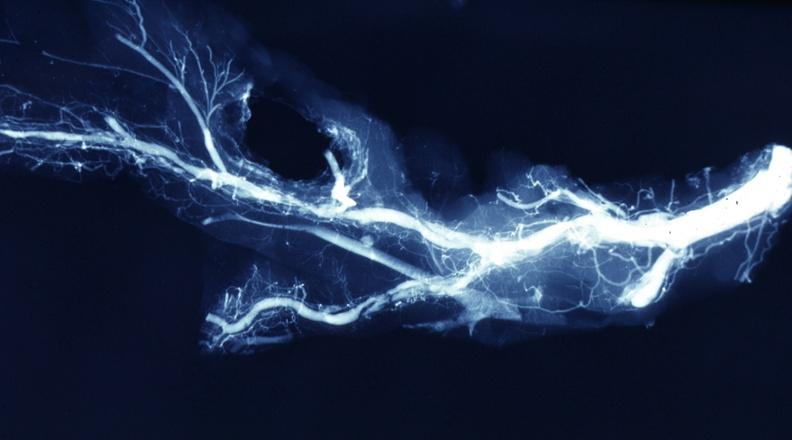does this image show x-ray postmortdissected artery lesions in small branches?
Answer the question using a single word or phrase. Yes 